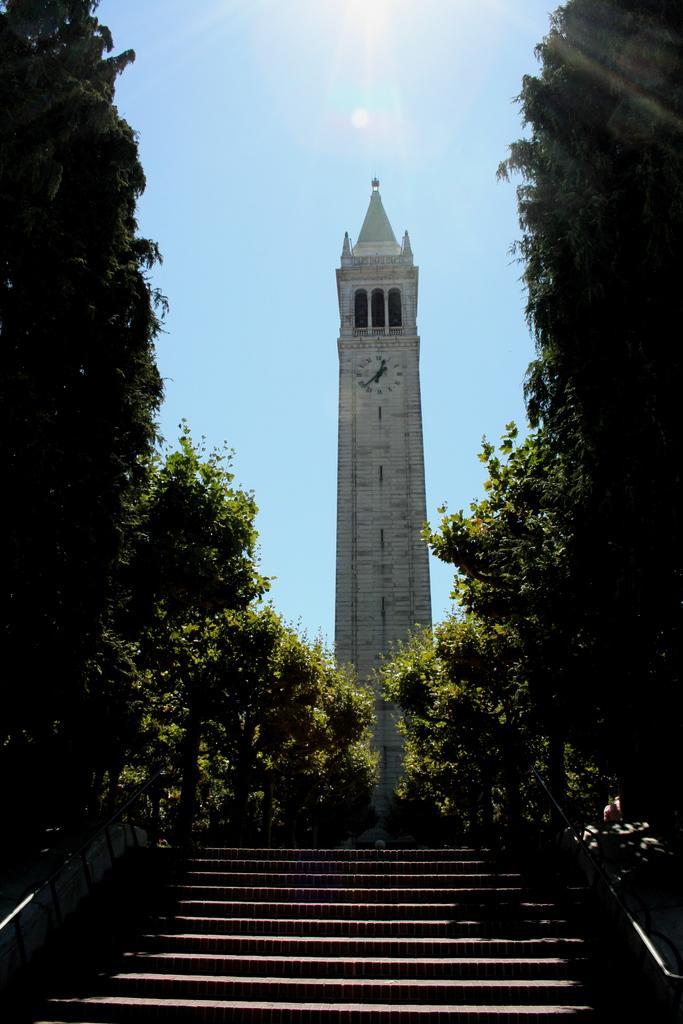Could you give a brief overview of what you see in this image? In this picture we can see few steps and a tower, beside to the tower we can find few trees, and also we can find a clock on the tower. 